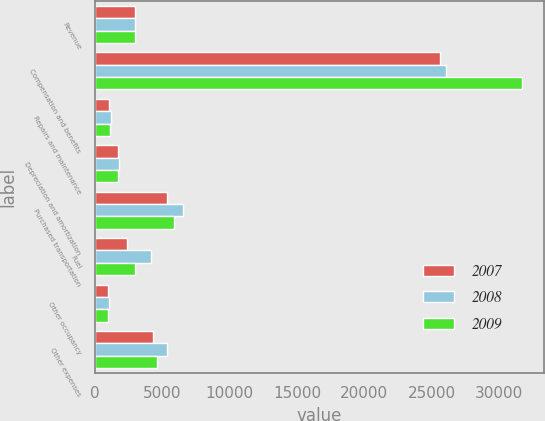<chart> <loc_0><loc_0><loc_500><loc_500><stacked_bar_chart><ecel><fcel>Revenue<fcel>Compensation and benefits<fcel>Repairs and maintenance<fcel>Depreciation and amortization<fcel>Purchased transportation<fcel>Fuel<fcel>Other occupancy<fcel>Other expenses<nl><fcel>2007<fcel>2974<fcel>25640<fcel>1075<fcel>1747<fcel>5379<fcel>2365<fcel>985<fcel>4305<nl><fcel>2008<fcel>2974<fcel>26063<fcel>1194<fcel>1814<fcel>6550<fcel>4134<fcel>1027<fcel>5322<nl><fcel>2009<fcel>2974<fcel>31745<fcel>1157<fcel>1745<fcel>5902<fcel>2974<fcel>958<fcel>4633<nl></chart> 